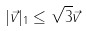<formula> <loc_0><loc_0><loc_500><loc_500>| \vec { v } | _ { 1 } \leq \sqrt { 3 } \| \vec { v } \|</formula> 